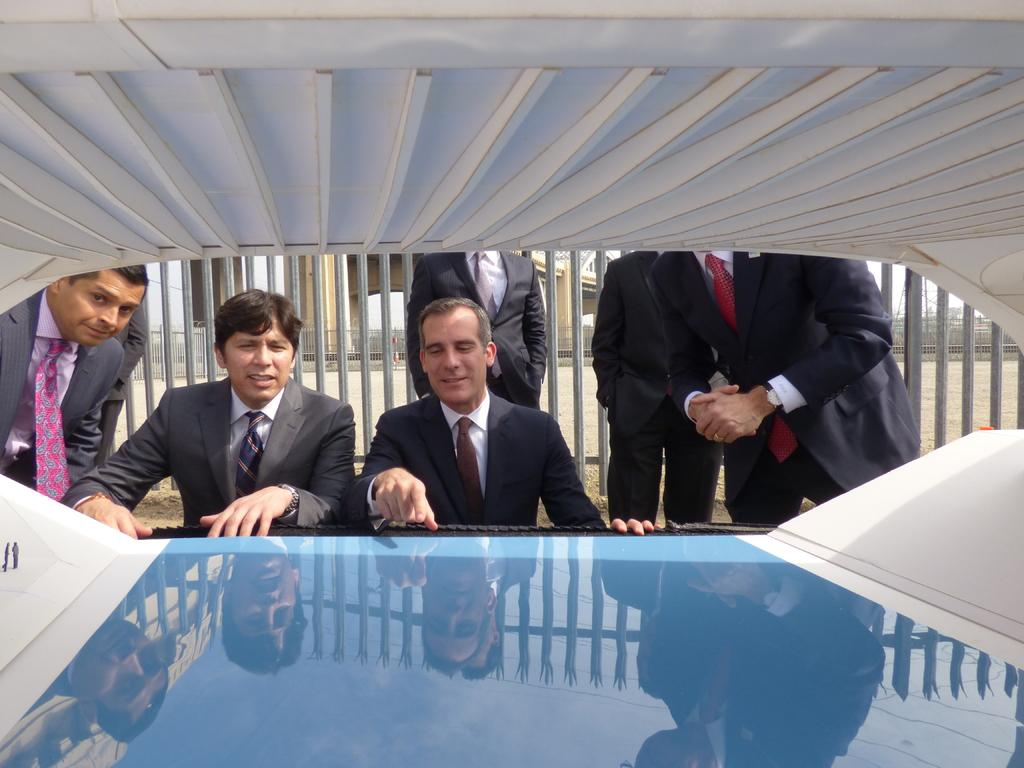What is happening in the image? There are people standing in the image. What is in front of the people? There is an object in front of the people. What is behind the people? There is an iron fence behind the people. Can you describe any other elements in the image? There are other unspecified elements in the image. How many ducks are sitting on the pear in the image? There are no ducks or pears present in the image. What type of chain is being used to secure the object in the image? There is no chain visible in the image. 